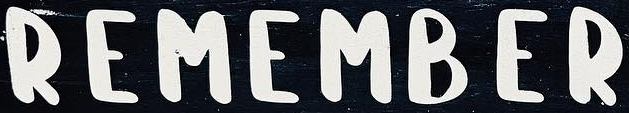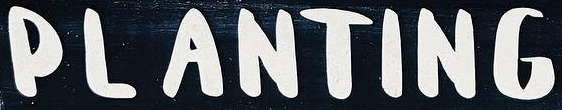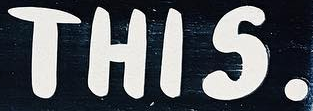Read the text content from these images in order, separated by a semicolon. REMAMBER; PLANTING; THIS. 